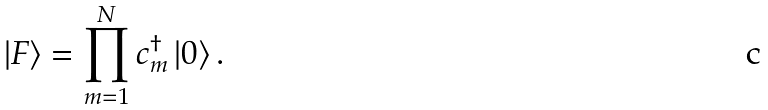<formula> <loc_0><loc_0><loc_500><loc_500>\left | F \right > = \prod _ { m = 1 } ^ { N } c ^ { \dagger } _ { m } \left | 0 \right > .</formula> 